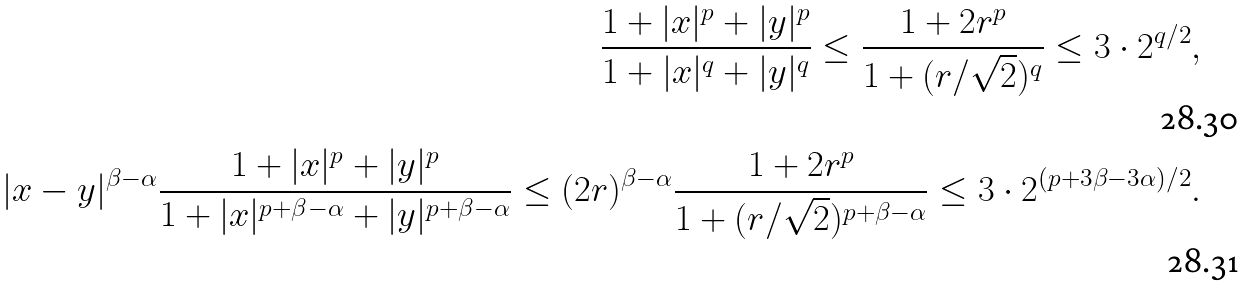<formula> <loc_0><loc_0><loc_500><loc_500>\frac { 1 + | x | ^ { p } + | y | ^ { p } } { 1 + | x | ^ { q } + | y | ^ { q } } \leq \frac { 1 + 2 r ^ { p } } { 1 + ( r / \sqrt { 2 } ) ^ { q } } \leq 3 \cdot 2 ^ { q / 2 } , \\ | x - y | ^ { \beta - \alpha } \frac { 1 + | x | ^ { p } + | y | ^ { p } } { 1 + | x | ^ { p + \beta - \alpha } + | y | ^ { p + \beta - \alpha } } \leq ( 2 r ) ^ { \beta - \alpha } \frac { 1 + 2 r ^ { p } } { 1 + ( r / \sqrt { 2 } ) ^ { p + \beta - \alpha } } \leq 3 \cdot 2 ^ { ( p + 3 \beta - 3 \alpha ) / 2 } .</formula> 